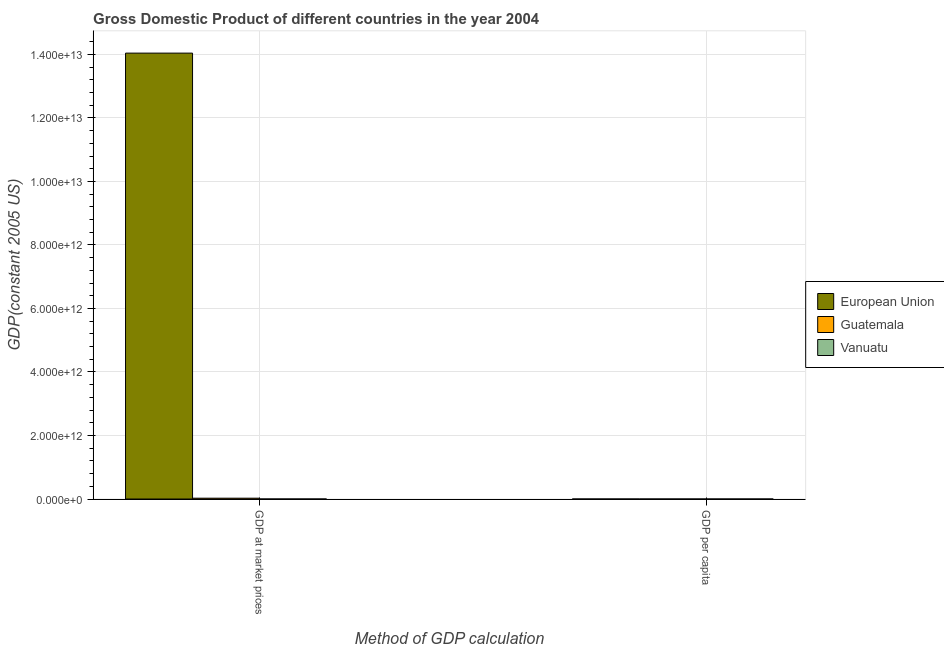How many different coloured bars are there?
Provide a succinct answer. 3. Are the number of bars on each tick of the X-axis equal?
Offer a terse response. Yes. How many bars are there on the 2nd tick from the right?
Your response must be concise. 3. What is the label of the 1st group of bars from the left?
Your response must be concise. GDP at market prices. What is the gdp per capita in European Union?
Keep it short and to the point. 2.84e+04. Across all countries, what is the maximum gdp at market prices?
Ensure brevity in your answer.  1.40e+13. Across all countries, what is the minimum gdp at market prices?
Offer a very short reply. 3.75e+08. In which country was the gdp per capita maximum?
Ensure brevity in your answer.  European Union. In which country was the gdp at market prices minimum?
Your response must be concise. Vanuatu. What is the total gdp at market prices in the graph?
Your response must be concise. 1.41e+13. What is the difference between the gdp at market prices in Guatemala and that in Vanuatu?
Make the answer very short. 2.60e+1. What is the difference between the gdp per capita in Vanuatu and the gdp at market prices in European Union?
Make the answer very short. -1.40e+13. What is the average gdp per capita per country?
Your response must be concise. 1.08e+04. What is the difference between the gdp per capita and gdp at market prices in European Union?
Provide a short and direct response. -1.40e+13. What is the ratio of the gdp per capita in Guatemala to that in European Union?
Provide a succinct answer. 0.07. In how many countries, is the gdp at market prices greater than the average gdp at market prices taken over all countries?
Keep it short and to the point. 1. What does the 2nd bar from the left in GDP at market prices represents?
Your answer should be very brief. Guatemala. How many bars are there?
Offer a very short reply. 6. Are all the bars in the graph horizontal?
Offer a very short reply. No. What is the difference between two consecutive major ticks on the Y-axis?
Provide a succinct answer. 2.00e+12. Does the graph contain any zero values?
Provide a short and direct response. No. How many legend labels are there?
Offer a very short reply. 3. How are the legend labels stacked?
Make the answer very short. Vertical. What is the title of the graph?
Ensure brevity in your answer.  Gross Domestic Product of different countries in the year 2004. Does "Australia" appear as one of the legend labels in the graph?
Offer a terse response. No. What is the label or title of the X-axis?
Offer a very short reply. Method of GDP calculation. What is the label or title of the Y-axis?
Your answer should be very brief. GDP(constant 2005 US). What is the GDP(constant 2005 US) of European Union in GDP at market prices?
Your answer should be compact. 1.40e+13. What is the GDP(constant 2005 US) of Guatemala in GDP at market prices?
Provide a succinct answer. 2.64e+1. What is the GDP(constant 2005 US) of Vanuatu in GDP at market prices?
Offer a very short reply. 3.75e+08. What is the GDP(constant 2005 US) in European Union in GDP per capita?
Ensure brevity in your answer.  2.84e+04. What is the GDP(constant 2005 US) of Guatemala in GDP per capita?
Your answer should be very brief. 2046.35. What is the GDP(constant 2005 US) in Vanuatu in GDP per capita?
Keep it short and to the point. 1837.3. Across all Method of GDP calculation, what is the maximum GDP(constant 2005 US) of European Union?
Your response must be concise. 1.40e+13. Across all Method of GDP calculation, what is the maximum GDP(constant 2005 US) in Guatemala?
Your answer should be compact. 2.64e+1. Across all Method of GDP calculation, what is the maximum GDP(constant 2005 US) in Vanuatu?
Your answer should be compact. 3.75e+08. Across all Method of GDP calculation, what is the minimum GDP(constant 2005 US) in European Union?
Your response must be concise. 2.84e+04. Across all Method of GDP calculation, what is the minimum GDP(constant 2005 US) in Guatemala?
Provide a short and direct response. 2046.35. Across all Method of GDP calculation, what is the minimum GDP(constant 2005 US) in Vanuatu?
Offer a very short reply. 1837.3. What is the total GDP(constant 2005 US) in European Union in the graph?
Ensure brevity in your answer.  1.40e+13. What is the total GDP(constant 2005 US) in Guatemala in the graph?
Make the answer very short. 2.64e+1. What is the total GDP(constant 2005 US) in Vanuatu in the graph?
Keep it short and to the point. 3.75e+08. What is the difference between the GDP(constant 2005 US) in European Union in GDP at market prices and that in GDP per capita?
Your response must be concise. 1.40e+13. What is the difference between the GDP(constant 2005 US) of Guatemala in GDP at market prices and that in GDP per capita?
Make the answer very short. 2.64e+1. What is the difference between the GDP(constant 2005 US) of Vanuatu in GDP at market prices and that in GDP per capita?
Provide a succinct answer. 3.75e+08. What is the difference between the GDP(constant 2005 US) of European Union in GDP at market prices and the GDP(constant 2005 US) of Guatemala in GDP per capita?
Your response must be concise. 1.40e+13. What is the difference between the GDP(constant 2005 US) of European Union in GDP at market prices and the GDP(constant 2005 US) of Vanuatu in GDP per capita?
Make the answer very short. 1.40e+13. What is the difference between the GDP(constant 2005 US) of Guatemala in GDP at market prices and the GDP(constant 2005 US) of Vanuatu in GDP per capita?
Provide a short and direct response. 2.64e+1. What is the average GDP(constant 2005 US) of European Union per Method of GDP calculation?
Your response must be concise. 7.02e+12. What is the average GDP(constant 2005 US) in Guatemala per Method of GDP calculation?
Your answer should be very brief. 1.32e+1. What is the average GDP(constant 2005 US) in Vanuatu per Method of GDP calculation?
Keep it short and to the point. 1.88e+08. What is the difference between the GDP(constant 2005 US) in European Union and GDP(constant 2005 US) in Guatemala in GDP at market prices?
Your answer should be compact. 1.40e+13. What is the difference between the GDP(constant 2005 US) of European Union and GDP(constant 2005 US) of Vanuatu in GDP at market prices?
Provide a short and direct response. 1.40e+13. What is the difference between the GDP(constant 2005 US) in Guatemala and GDP(constant 2005 US) in Vanuatu in GDP at market prices?
Your answer should be very brief. 2.60e+1. What is the difference between the GDP(constant 2005 US) of European Union and GDP(constant 2005 US) of Guatemala in GDP per capita?
Provide a succinct answer. 2.64e+04. What is the difference between the GDP(constant 2005 US) in European Union and GDP(constant 2005 US) in Vanuatu in GDP per capita?
Keep it short and to the point. 2.66e+04. What is the difference between the GDP(constant 2005 US) in Guatemala and GDP(constant 2005 US) in Vanuatu in GDP per capita?
Your response must be concise. 209.05. What is the ratio of the GDP(constant 2005 US) in European Union in GDP at market prices to that in GDP per capita?
Offer a very short reply. 4.94e+08. What is the ratio of the GDP(constant 2005 US) in Guatemala in GDP at market prices to that in GDP per capita?
Provide a succinct answer. 1.29e+07. What is the ratio of the GDP(constant 2005 US) in Vanuatu in GDP at market prices to that in GDP per capita?
Your answer should be compact. 2.04e+05. What is the difference between the highest and the second highest GDP(constant 2005 US) of European Union?
Give a very brief answer. 1.40e+13. What is the difference between the highest and the second highest GDP(constant 2005 US) in Guatemala?
Offer a terse response. 2.64e+1. What is the difference between the highest and the second highest GDP(constant 2005 US) of Vanuatu?
Your answer should be compact. 3.75e+08. What is the difference between the highest and the lowest GDP(constant 2005 US) of European Union?
Offer a very short reply. 1.40e+13. What is the difference between the highest and the lowest GDP(constant 2005 US) of Guatemala?
Provide a short and direct response. 2.64e+1. What is the difference between the highest and the lowest GDP(constant 2005 US) of Vanuatu?
Provide a short and direct response. 3.75e+08. 